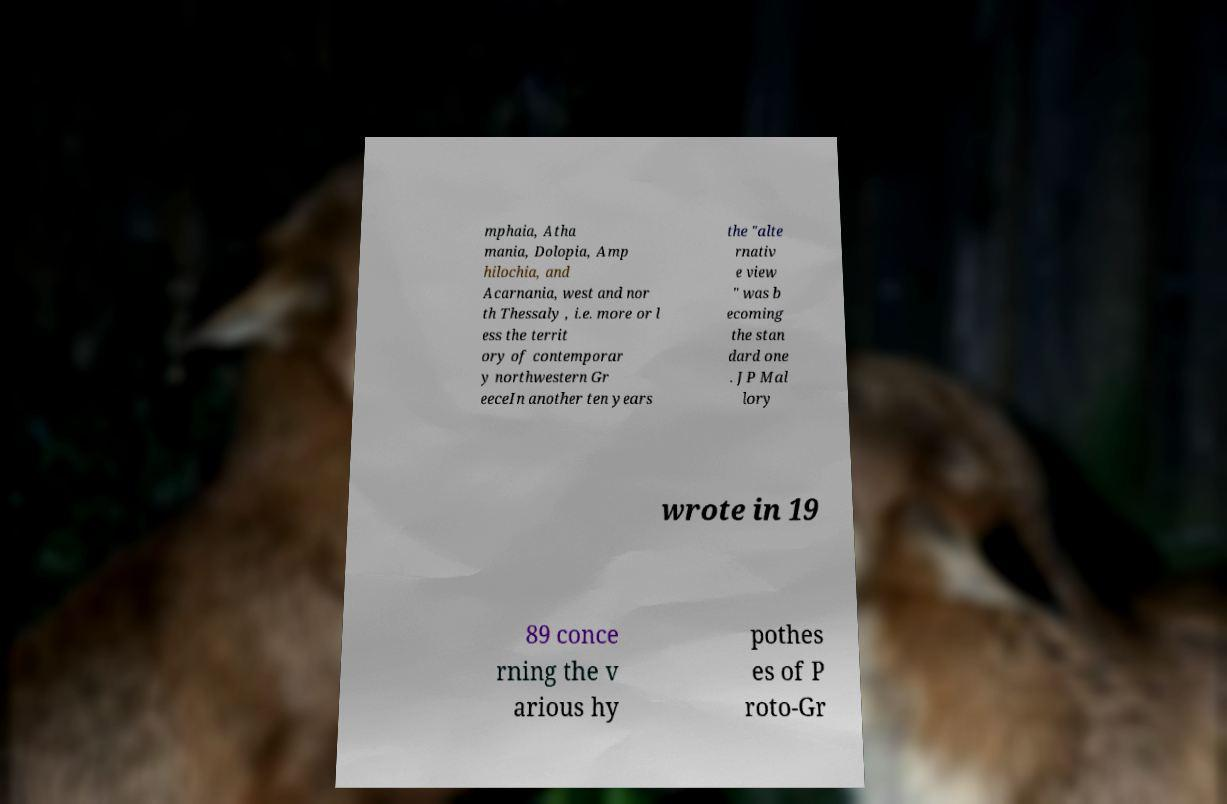Please identify and transcribe the text found in this image. mphaia, Atha mania, Dolopia, Amp hilochia, and Acarnania, west and nor th Thessaly , i.e. more or l ess the territ ory of contemporar y northwestern Gr eeceIn another ten years the "alte rnativ e view " was b ecoming the stan dard one . JP Mal lory wrote in 19 89 conce rning the v arious hy pothes es of P roto-Gr 